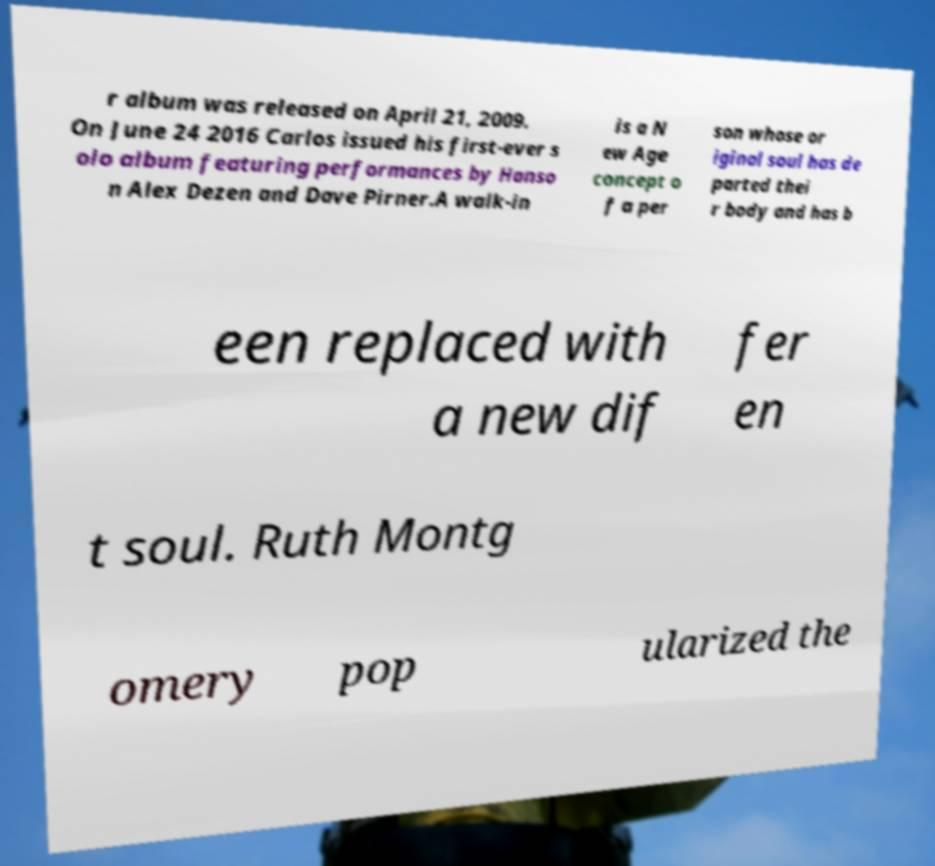Please identify and transcribe the text found in this image. r album was released on April 21, 2009. On June 24 2016 Carlos issued his first-ever s olo album featuring performances by Hanso n Alex Dezen and Dave Pirner.A walk-in is a N ew Age concept o f a per son whose or iginal soul has de parted thei r body and has b een replaced with a new dif fer en t soul. Ruth Montg omery pop ularized the 